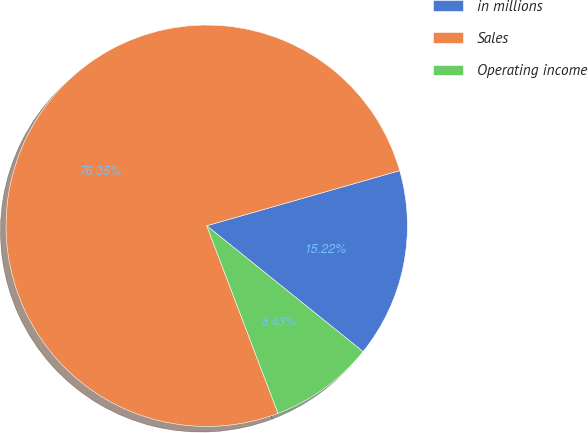Convert chart to OTSL. <chart><loc_0><loc_0><loc_500><loc_500><pie_chart><fcel>in millions<fcel>Sales<fcel>Operating income<nl><fcel>15.22%<fcel>76.35%<fcel>8.43%<nl></chart> 